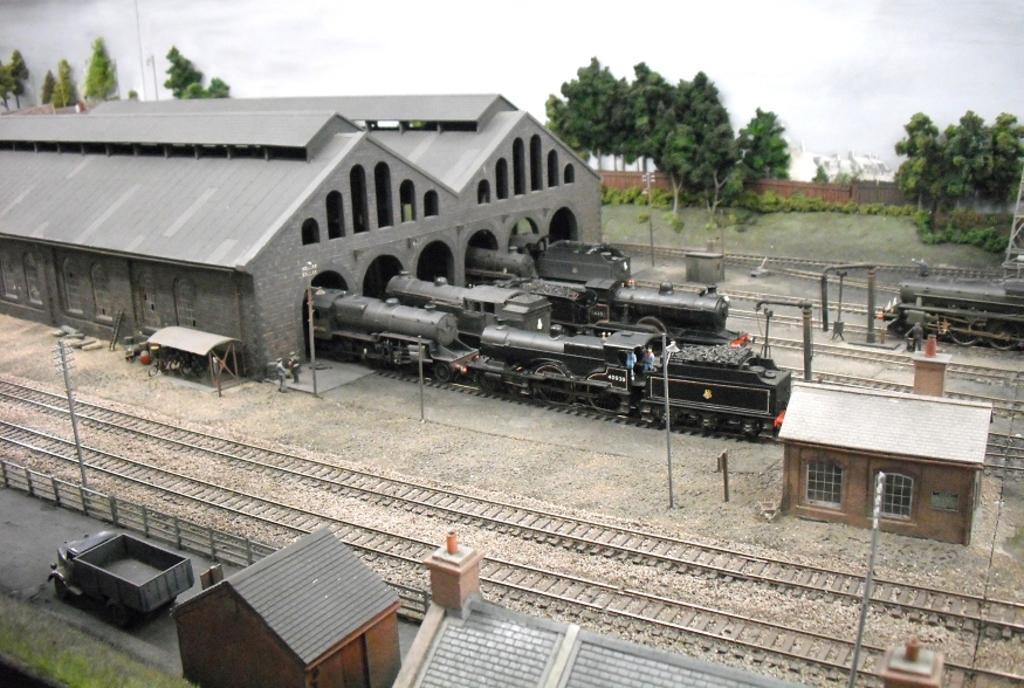Describe this image in one or two sentences. In the center of the image there is a shed with trains in it. At the bottom of the image there are railway tracks, poles. At the bottom of the image there is a house. In the background of the image there are trees. At the top of the image there is sky. 